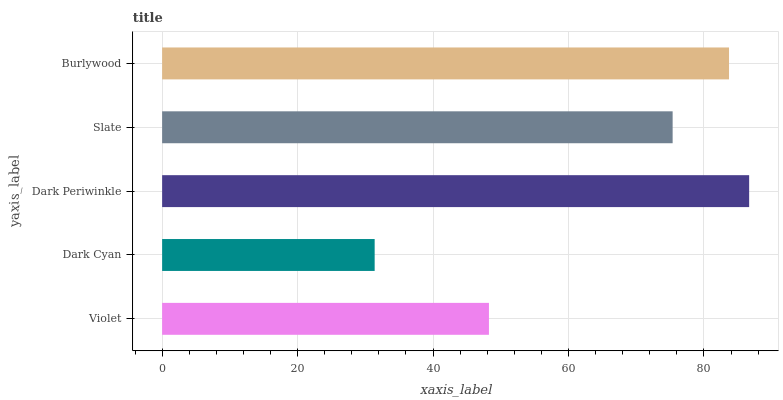Is Dark Cyan the minimum?
Answer yes or no. Yes. Is Dark Periwinkle the maximum?
Answer yes or no. Yes. Is Dark Periwinkle the minimum?
Answer yes or no. No. Is Dark Cyan the maximum?
Answer yes or no. No. Is Dark Periwinkle greater than Dark Cyan?
Answer yes or no. Yes. Is Dark Cyan less than Dark Periwinkle?
Answer yes or no. Yes. Is Dark Cyan greater than Dark Periwinkle?
Answer yes or no. No. Is Dark Periwinkle less than Dark Cyan?
Answer yes or no. No. Is Slate the high median?
Answer yes or no. Yes. Is Slate the low median?
Answer yes or no. Yes. Is Dark Periwinkle the high median?
Answer yes or no. No. Is Violet the low median?
Answer yes or no. No. 